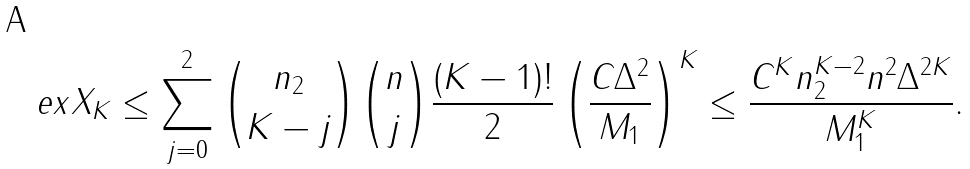<formula> <loc_0><loc_0><loc_500><loc_500>\ e x X _ { K } & \leq \sum _ { j = 0 } ^ { 2 } \binom { n _ { 2 } } { K - j } \binom { n } { j } \frac { ( K - 1 ) ! } { 2 } \left ( \frac { C \Delta ^ { 2 } } { M _ { 1 } } \right ) ^ { K } \leq \frac { C ^ { K } n _ { 2 } ^ { K - 2 } n ^ { 2 } \Delta ^ { 2 K } } { M _ { 1 } ^ { K } } .</formula> 